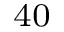Convert formula to latex. <formula><loc_0><loc_0><loc_500><loc_500>^ { 4 0 }</formula> 